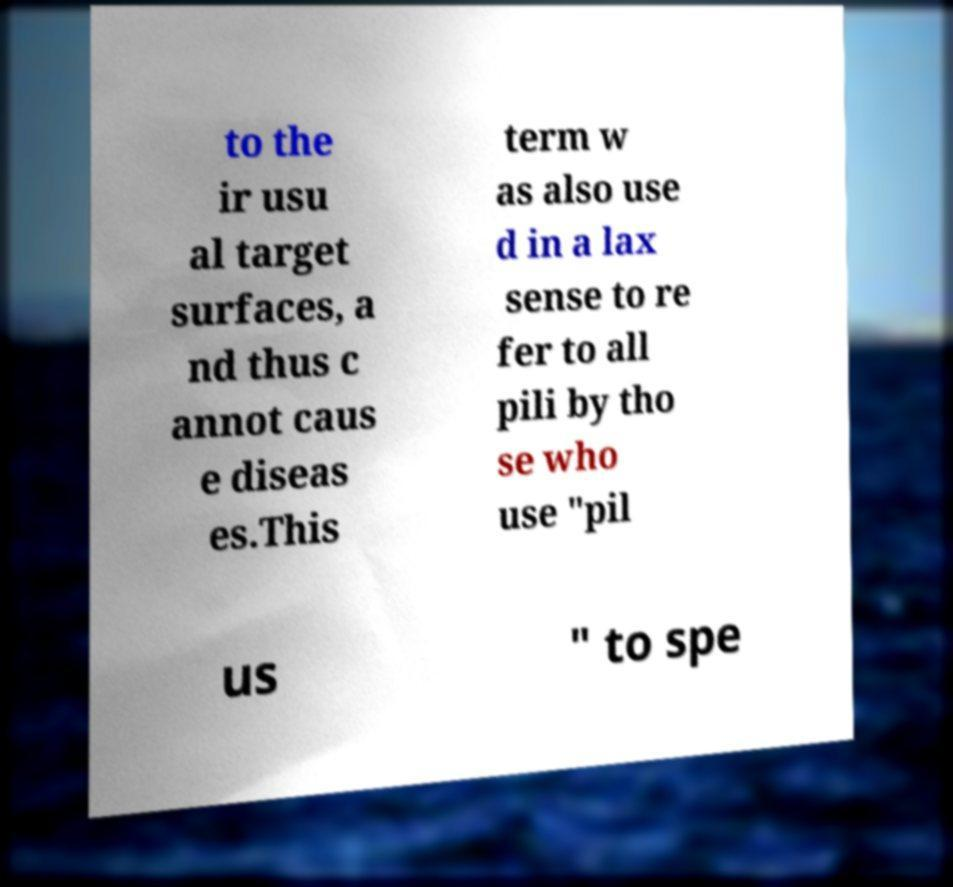What messages or text are displayed in this image? I need them in a readable, typed format. to the ir usu al target surfaces, a nd thus c annot caus e diseas es.This term w as also use d in a lax sense to re fer to all pili by tho se who use "pil us " to spe 